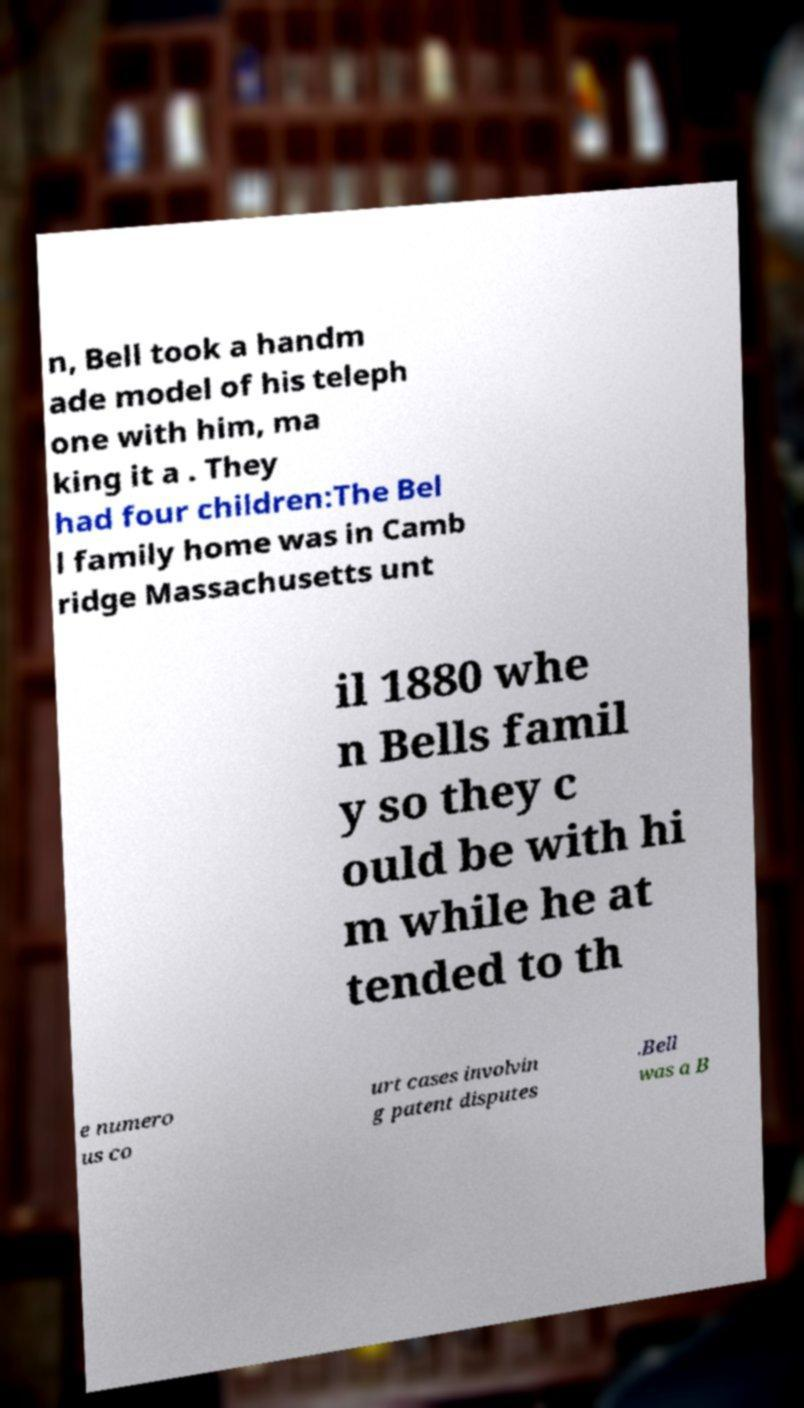There's text embedded in this image that I need extracted. Can you transcribe it verbatim? n, Bell took a handm ade model of his teleph one with him, ma king it a . They had four children:The Bel l family home was in Camb ridge Massachusetts unt il 1880 whe n Bells famil y so they c ould be with hi m while he at tended to th e numero us co urt cases involvin g patent disputes .Bell was a B 